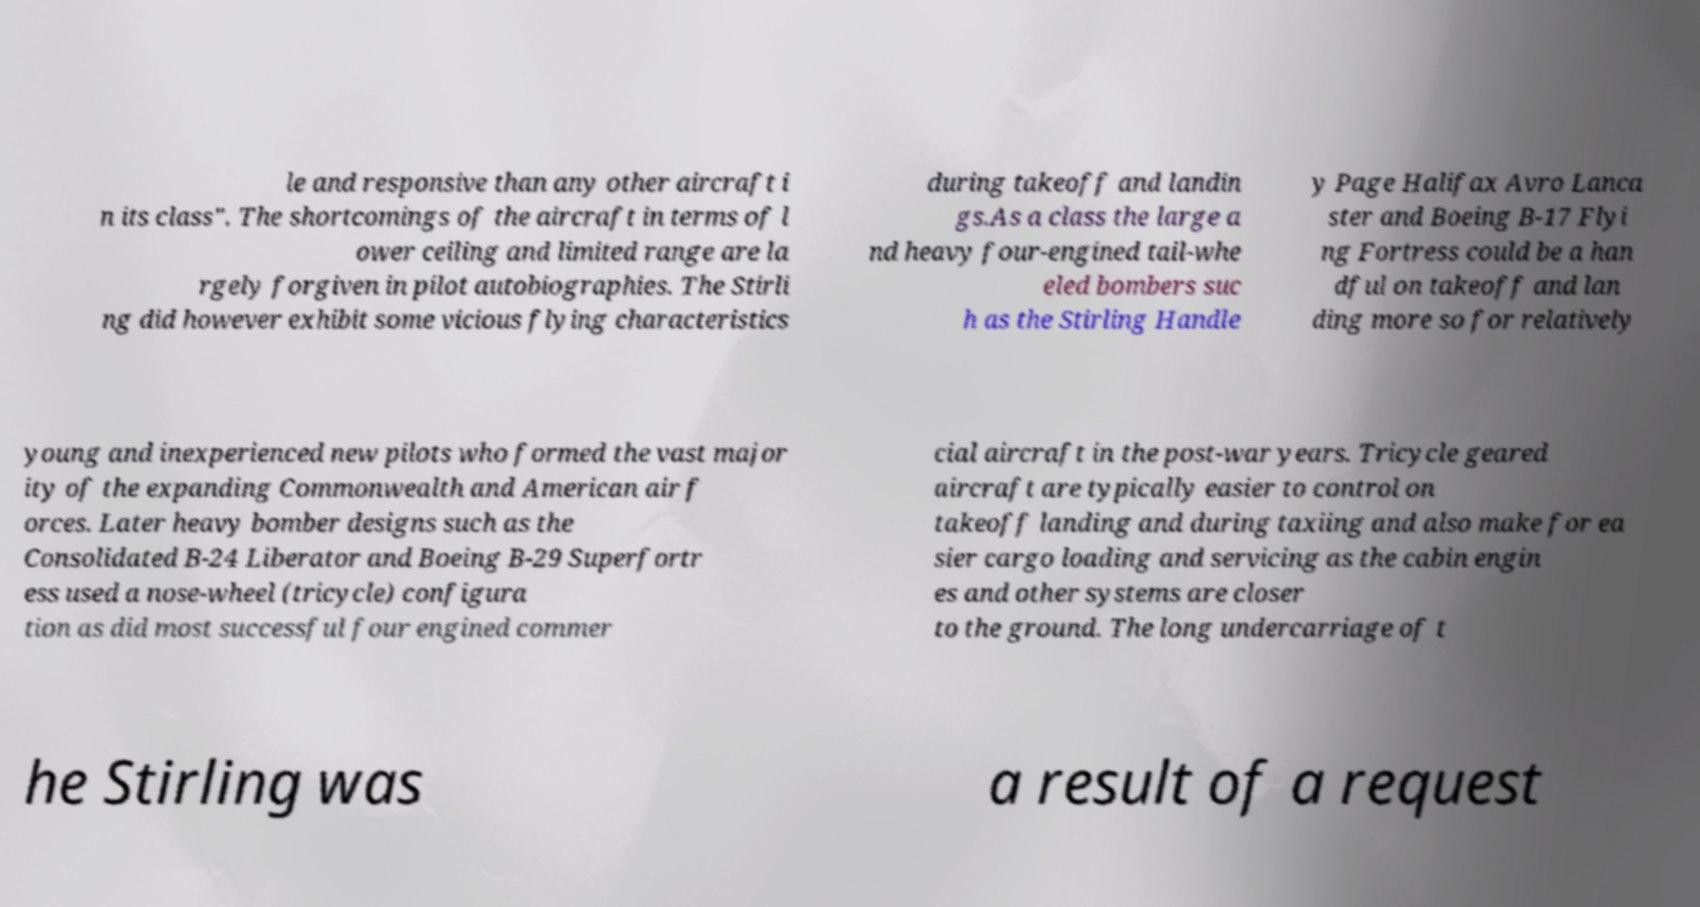There's text embedded in this image that I need extracted. Can you transcribe it verbatim? le and responsive than any other aircraft i n its class". The shortcomings of the aircraft in terms of l ower ceiling and limited range are la rgely forgiven in pilot autobiographies. The Stirli ng did however exhibit some vicious flying characteristics during takeoff and landin gs.As a class the large a nd heavy four-engined tail-whe eled bombers suc h as the Stirling Handle y Page Halifax Avro Lanca ster and Boeing B-17 Flyi ng Fortress could be a han dful on takeoff and lan ding more so for relatively young and inexperienced new pilots who formed the vast major ity of the expanding Commonwealth and American air f orces. Later heavy bomber designs such as the Consolidated B-24 Liberator and Boeing B-29 Superfortr ess used a nose-wheel (tricycle) configura tion as did most successful four engined commer cial aircraft in the post-war years. Tricycle geared aircraft are typically easier to control on takeoff landing and during taxiing and also make for ea sier cargo loading and servicing as the cabin engin es and other systems are closer to the ground. The long undercarriage of t he Stirling was a result of a request 